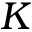Convert formula to latex. <formula><loc_0><loc_0><loc_500><loc_500>K</formula> 